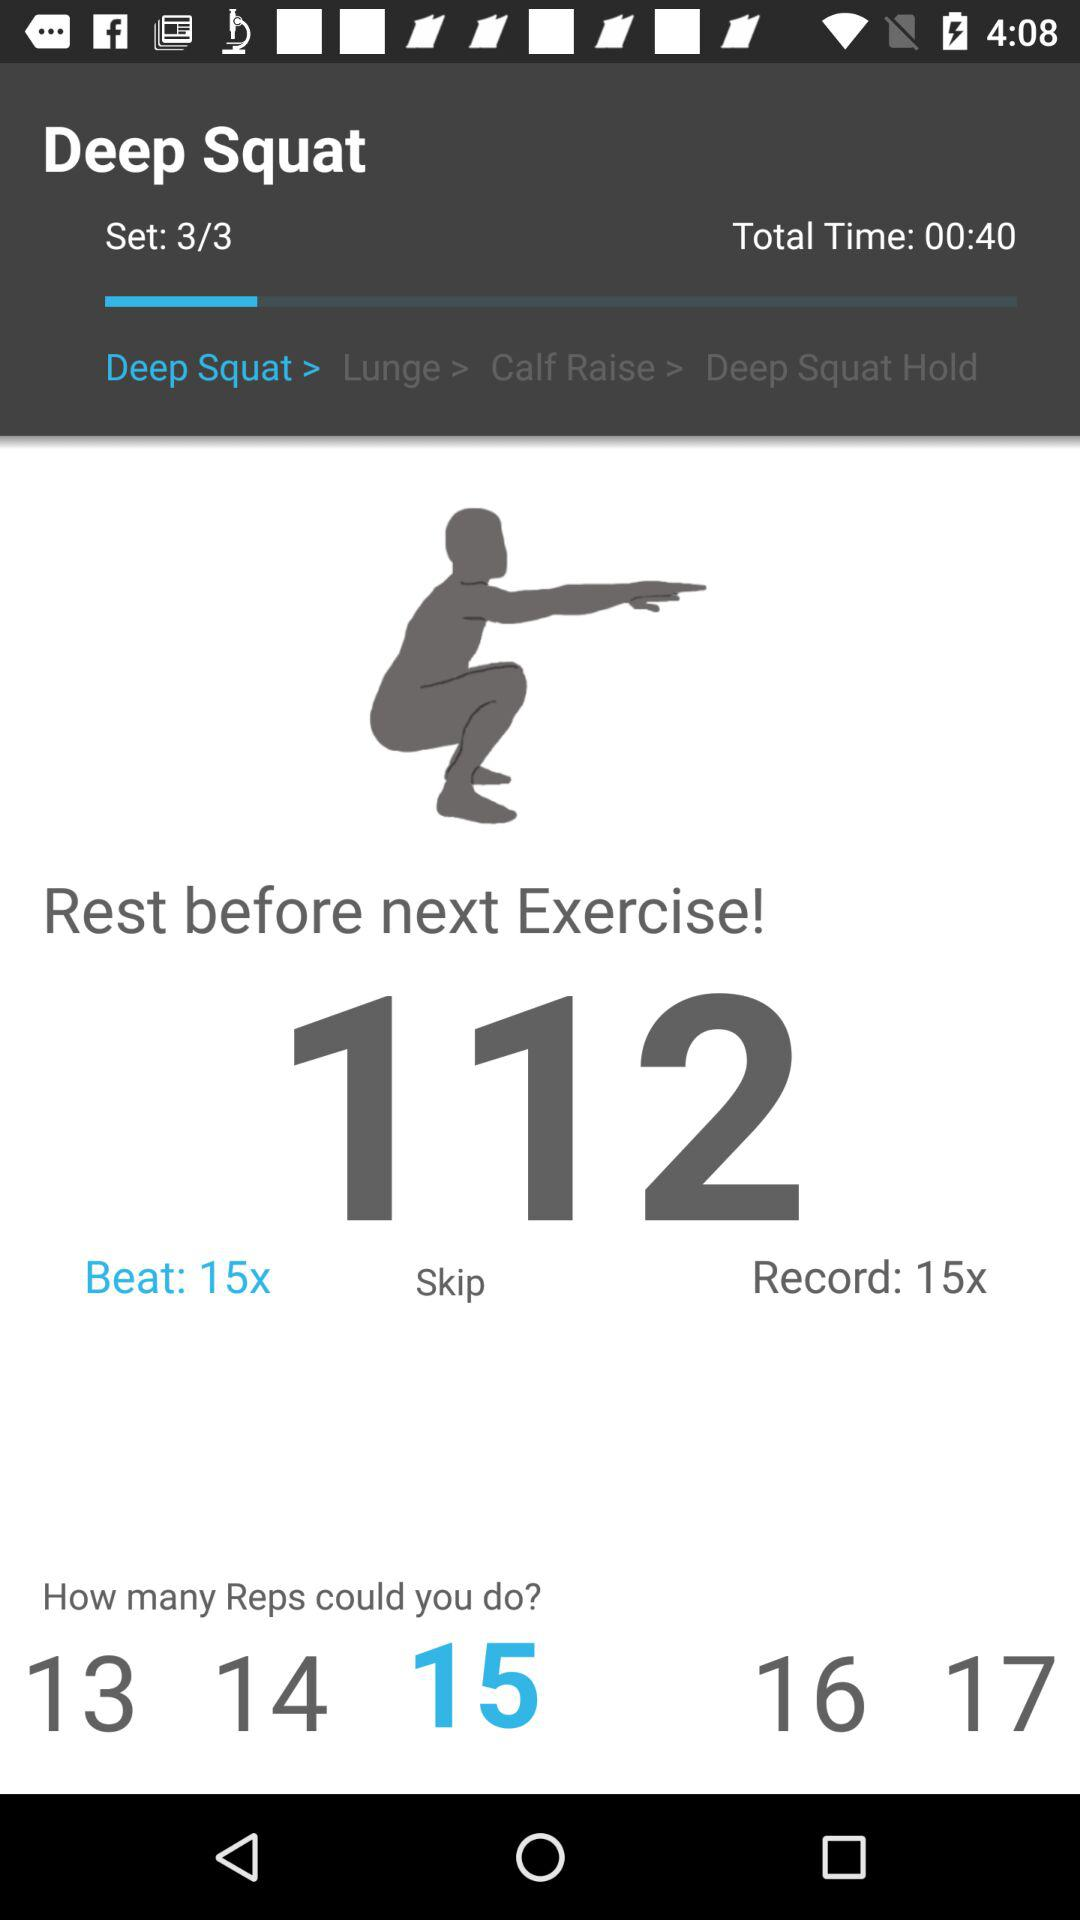How many repetitions can a user do? A user can do 15 repetitions. 